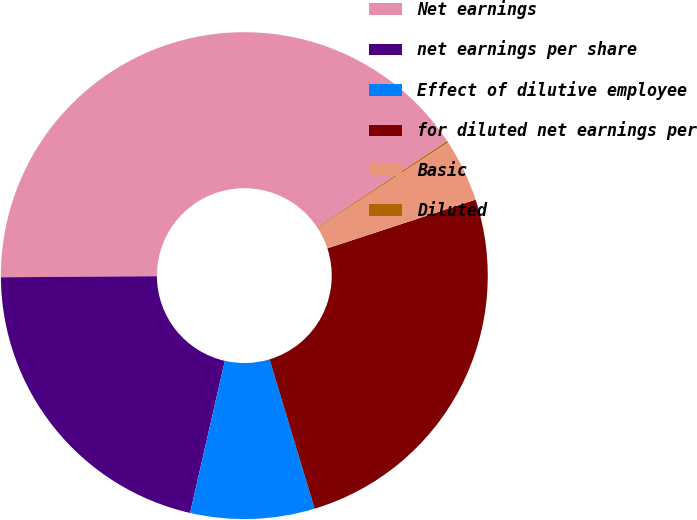<chart> <loc_0><loc_0><loc_500><loc_500><pie_chart><fcel>Net earnings<fcel>net earnings per share<fcel>Effect of dilutive employee<fcel>for diluted net earnings per<fcel>Basic<fcel>Diluted<nl><fcel>40.79%<fcel>21.32%<fcel>8.24%<fcel>25.39%<fcel>4.17%<fcel>0.1%<nl></chart> 